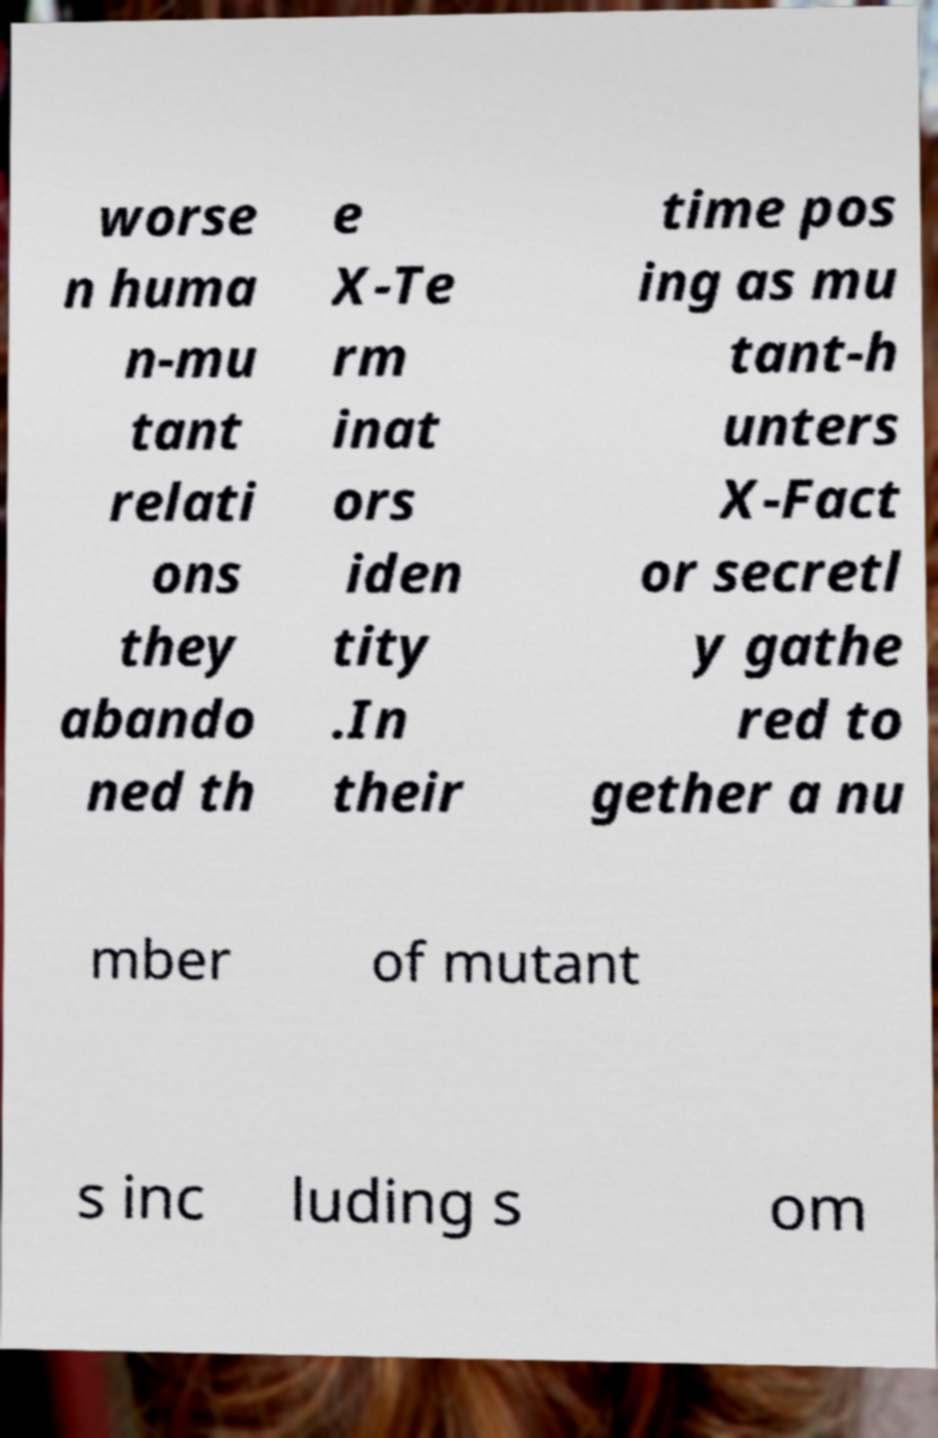What messages or text are displayed in this image? I need them in a readable, typed format. worse n huma n-mu tant relati ons they abando ned th e X-Te rm inat ors iden tity .In their time pos ing as mu tant-h unters X-Fact or secretl y gathe red to gether a nu mber of mutant s inc luding s om 